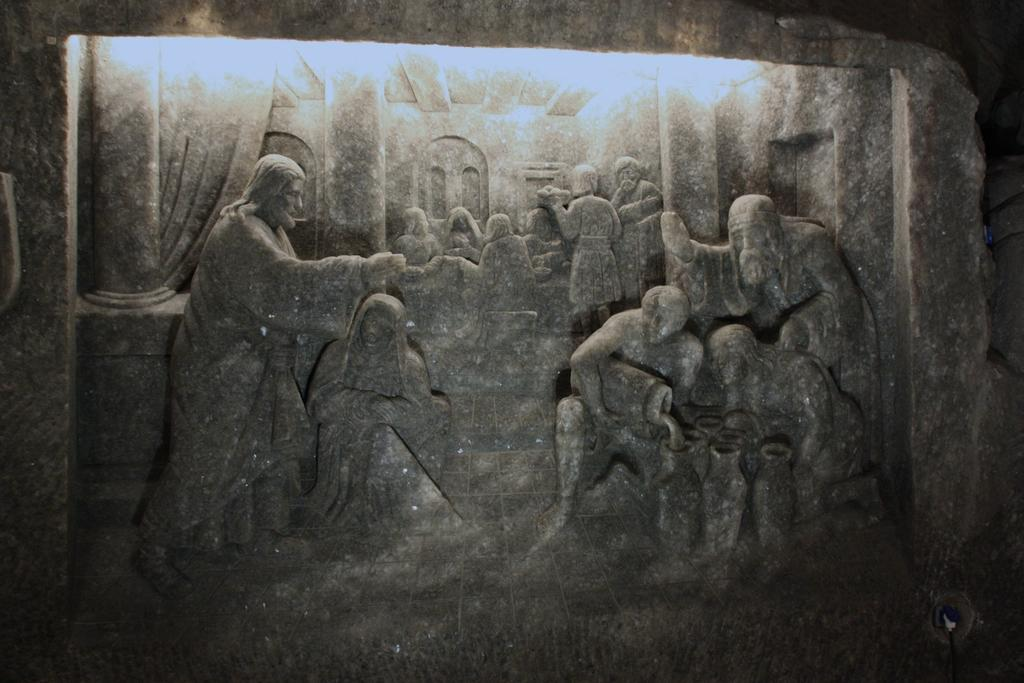What type of structure can be seen in the image? There is a wall in the image. What decorative elements are present on the wall? There are stone carved statues in the image. What can be seen at the top of the image? There are lights visible at the top of the image. Can you see a boat floating in the water near the wall in the image? There is no boat or water present in the image. What type of stick can be seen being used by the statues in the image? There are no sticks present in the image, and the statues are not shown using any objects. 